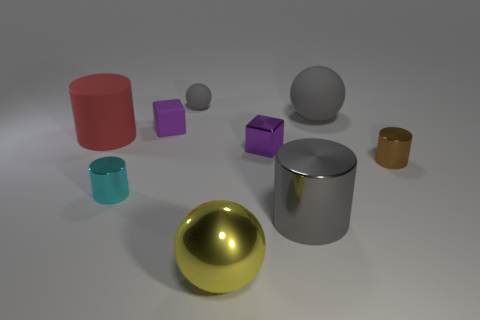How many purple blocks are there?
Ensure brevity in your answer.  2. Do the tiny cyan metal object and the small purple thing that is behind the purple metal cube have the same shape?
Offer a very short reply. No. Are there fewer gray metal objects behind the large yellow metal object than purple things that are to the left of the gray shiny cylinder?
Your response must be concise. Yes. Does the small cyan thing have the same shape as the small purple matte thing?
Your answer should be very brief. No. What is the size of the brown thing?
Offer a very short reply. Small. The object that is both behind the purple shiny object and in front of the small purple rubber thing is what color?
Provide a short and direct response. Red. Are there more small metal cubes than small purple cylinders?
Provide a short and direct response. Yes. What number of objects are tiny gray balls or spheres behind the small brown metallic cylinder?
Your answer should be compact. 2. Do the brown cylinder and the red object have the same size?
Offer a very short reply. No. There is a small purple rubber object; are there any cylinders left of it?
Give a very brief answer. Yes. 